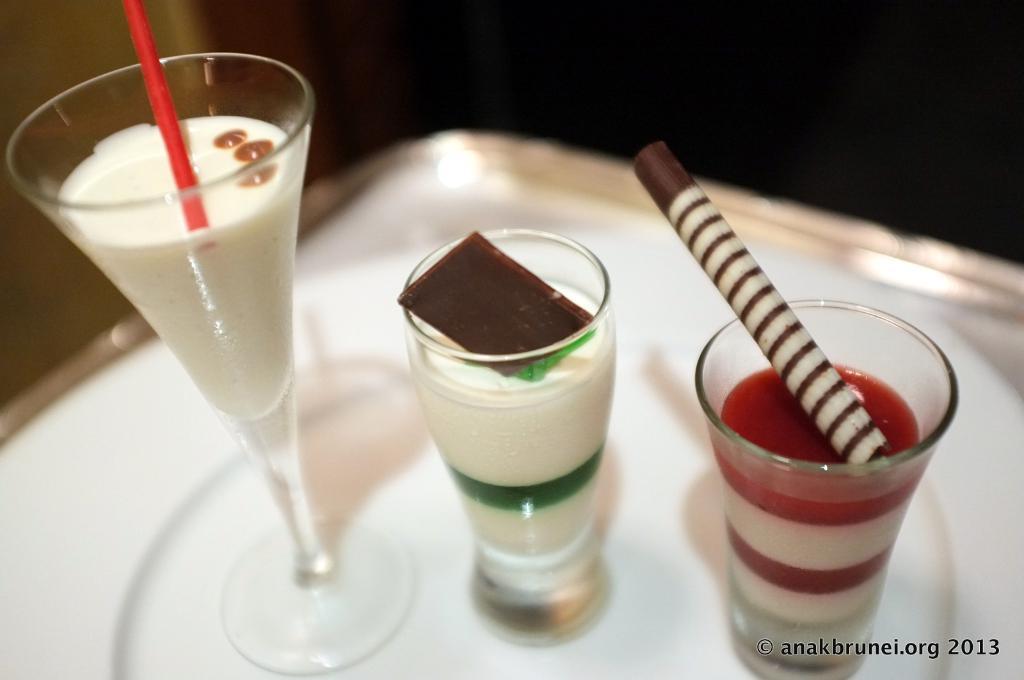In one or two sentences, can you explain what this image depicts? There is a tray. On the train there are glasses with different drinks. In the right bottom corner there is a watermark. 